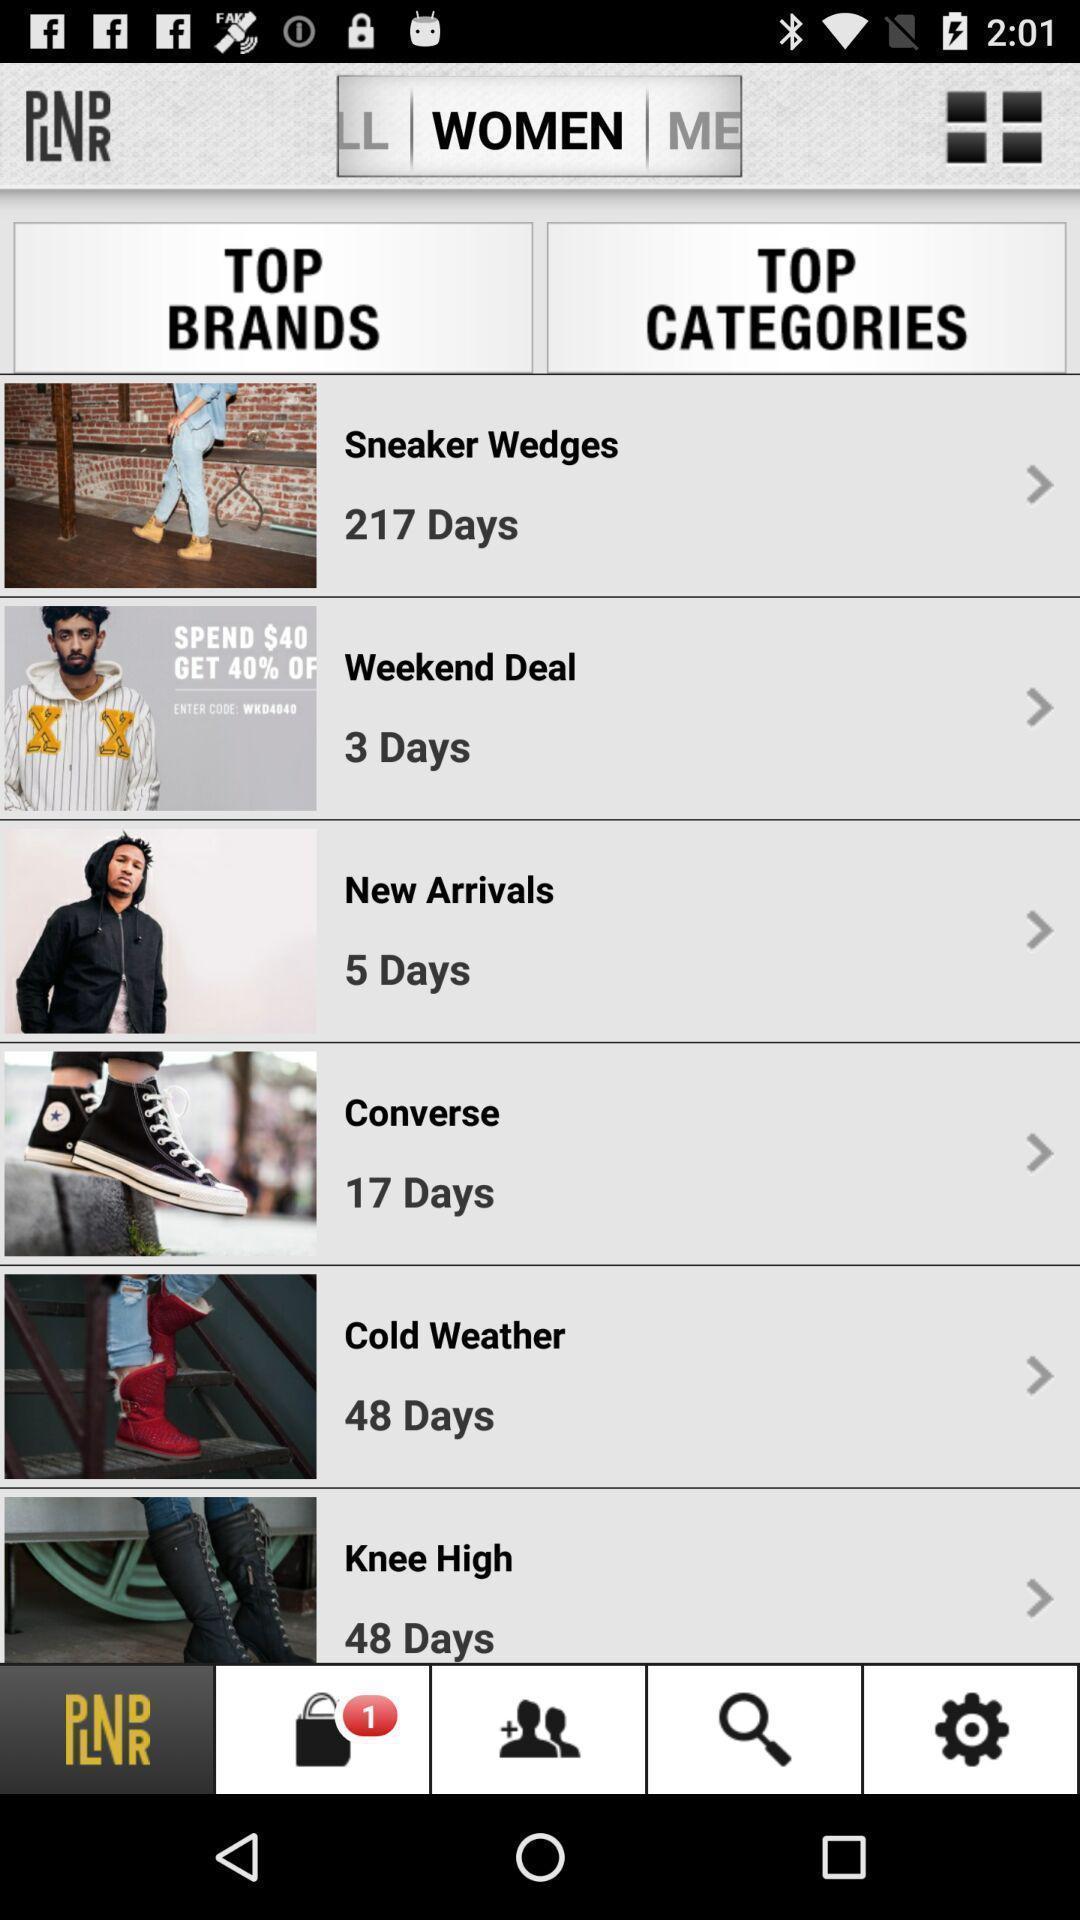What can you discern from this picture? Screen showing top brands and top categories. 